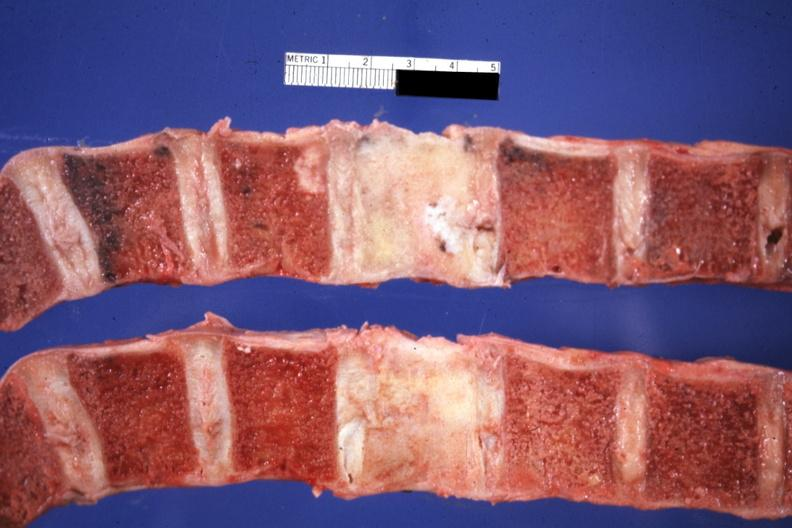what is present?
Answer the question using a single word or phrase. Joints 